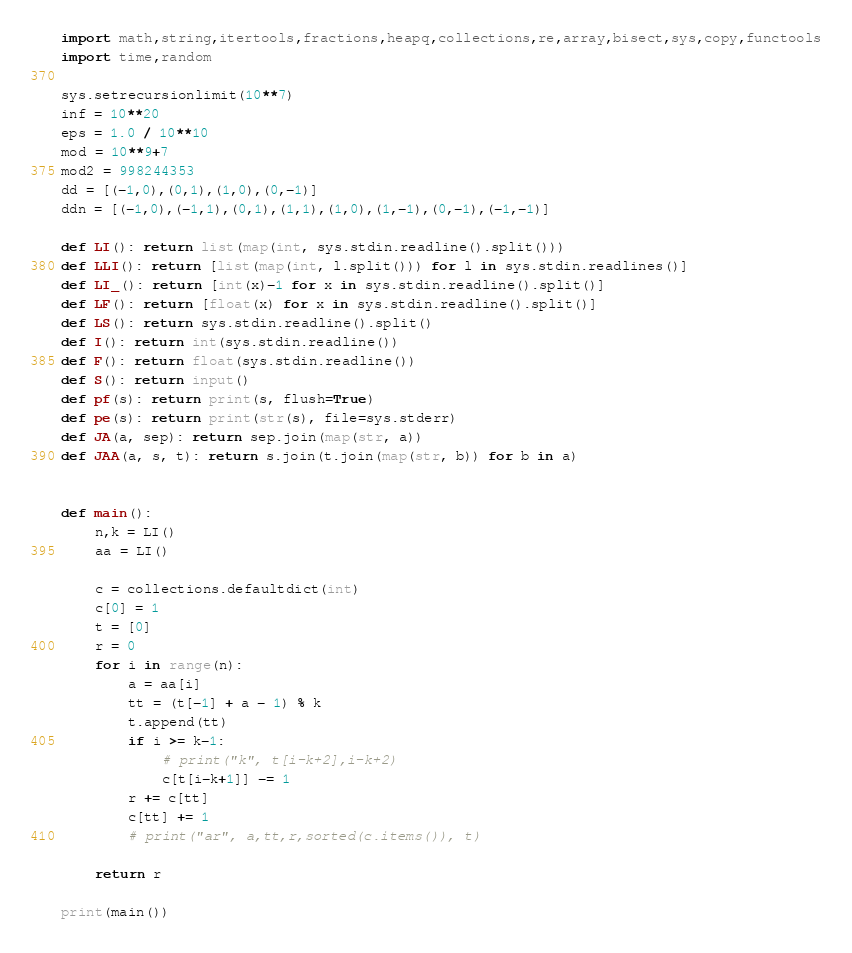Convert code to text. <code><loc_0><loc_0><loc_500><loc_500><_Python_>import math,string,itertools,fractions,heapq,collections,re,array,bisect,sys,copy,functools
import time,random

sys.setrecursionlimit(10**7)
inf = 10**20
eps = 1.0 / 10**10
mod = 10**9+7
mod2 = 998244353
dd = [(-1,0),(0,1),(1,0),(0,-1)]
ddn = [(-1,0),(-1,1),(0,1),(1,1),(1,0),(1,-1),(0,-1),(-1,-1)]

def LI(): return list(map(int, sys.stdin.readline().split()))
def LLI(): return [list(map(int, l.split())) for l in sys.stdin.readlines()]
def LI_(): return [int(x)-1 for x in sys.stdin.readline().split()]
def LF(): return [float(x) for x in sys.stdin.readline().split()]
def LS(): return sys.stdin.readline().split()
def I(): return int(sys.stdin.readline())
def F(): return float(sys.stdin.readline())
def S(): return input()
def pf(s): return print(s, flush=True)
def pe(s): return print(str(s), file=sys.stderr)
def JA(a, sep): return sep.join(map(str, a))
def JAA(a, s, t): return s.join(t.join(map(str, b)) for b in a)


def main():
    n,k = LI()
    aa = LI()

    c = collections.defaultdict(int)
    c[0] = 1
    t = [0]
    r = 0
    for i in range(n):
        a = aa[i]
        tt = (t[-1] + a - 1) % k
        t.append(tt)
        if i >= k-1:
            # print("k", t[i-k+2],i-k+2)
            c[t[i-k+1]] -= 1
        r += c[tt]
        c[tt] += 1
        # print("ar", a,tt,r,sorted(c.items()), t)

    return r

print(main())



</code> 